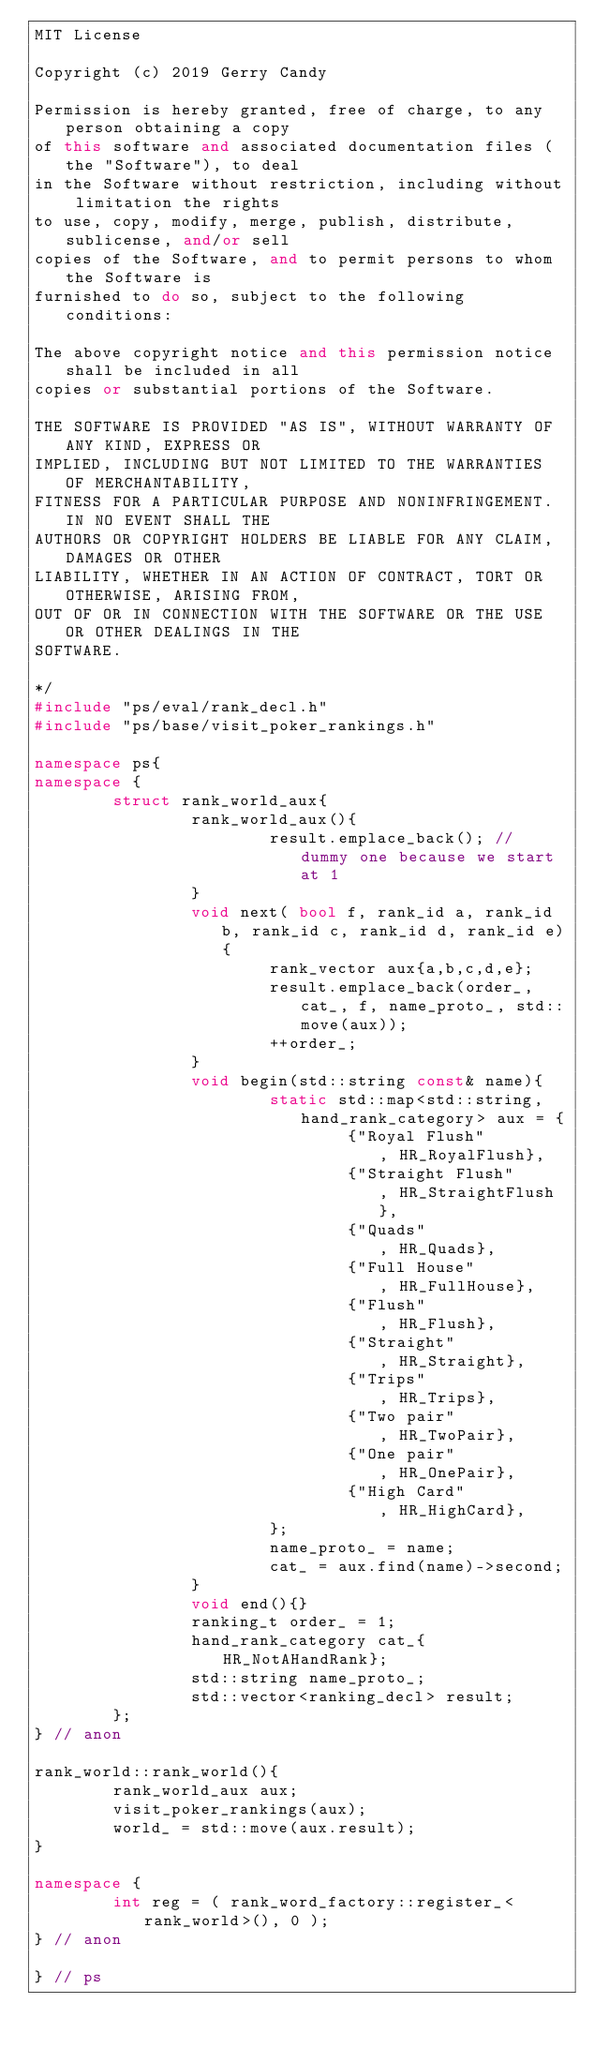Convert code to text. <code><loc_0><loc_0><loc_500><loc_500><_C++_>MIT License

Copyright (c) 2019 Gerry Candy

Permission is hereby granted, free of charge, to any person obtaining a copy
of this software and associated documentation files (the "Software"), to deal
in the Software without restriction, including without limitation the rights
to use, copy, modify, merge, publish, distribute, sublicense, and/or sell
copies of the Software, and to permit persons to whom the Software is
furnished to do so, subject to the following conditions:

The above copyright notice and this permission notice shall be included in all
copies or substantial portions of the Software.

THE SOFTWARE IS PROVIDED "AS IS", WITHOUT WARRANTY OF ANY KIND, EXPRESS OR
IMPLIED, INCLUDING BUT NOT LIMITED TO THE WARRANTIES OF MERCHANTABILITY,
FITNESS FOR A PARTICULAR PURPOSE AND NONINFRINGEMENT. IN NO EVENT SHALL THE
AUTHORS OR COPYRIGHT HOLDERS BE LIABLE FOR ANY CLAIM, DAMAGES OR OTHER
LIABILITY, WHETHER IN AN ACTION OF CONTRACT, TORT OR OTHERWISE, ARISING FROM,
OUT OF OR IN CONNECTION WITH THE SOFTWARE OR THE USE OR OTHER DEALINGS IN THE
SOFTWARE.

*/
#include "ps/eval/rank_decl.h"
#include "ps/base/visit_poker_rankings.h"

namespace ps{
namespace {
        struct rank_world_aux{
                rank_world_aux(){
                        result.emplace_back(); // dummy one because we start at 1
                }
                void next( bool f, rank_id a, rank_id b, rank_id c, rank_id d, rank_id e){
                        rank_vector aux{a,b,c,d,e};
                        result.emplace_back(order_, cat_, f, name_proto_, std::move(aux));
                        ++order_;
                }
                void begin(std::string const& name){
                        static std::map<std::string, hand_rank_category> aux = {
                                {"Royal Flush"        , HR_RoyalFlush},
                                {"Straight Flush"     , HR_StraightFlush},
                                {"Quads"              , HR_Quads},
                                {"Full House"         , HR_FullHouse},
                                {"Flush"              , HR_Flush},
                                {"Straight"           , HR_Straight},
                                {"Trips"              , HR_Trips},
                                {"Two pair"           , HR_TwoPair},
                                {"One pair"           , HR_OnePair},
                                {"High Card"          , HR_HighCard},
                        };
                        name_proto_ = name;
                        cat_ = aux.find(name)->second;
                }
                void end(){}
                ranking_t order_ = 1;
                hand_rank_category cat_{HR_NotAHandRank};
                std::string name_proto_;
                std::vector<ranking_decl> result;
        };
} // anon
                
rank_world::rank_world(){
        rank_world_aux aux;
        visit_poker_rankings(aux);
        world_ = std::move(aux.result);
}

namespace {
        int reg = ( rank_word_factory::register_<rank_world>(), 0 );
} // anon

} // ps
</code> 